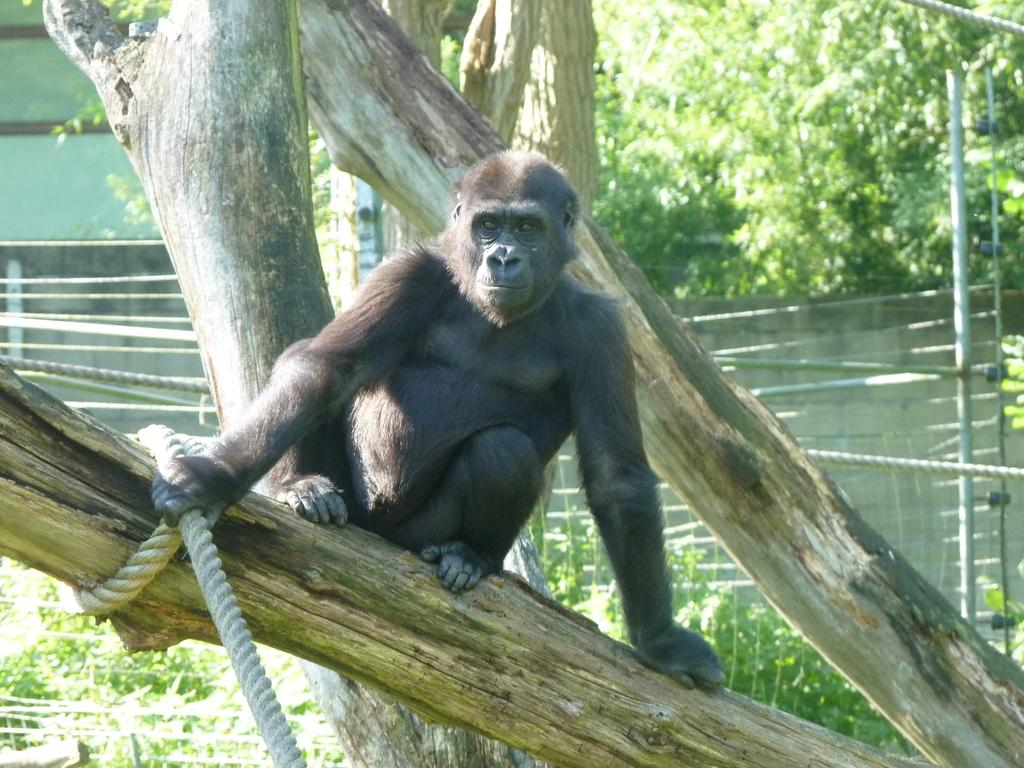What animal is present in the image? There is a chimpanzee in the image. Where is the chimpanzee located? The chimpanzee is on a branch of a tree. What is the chimpanzee holding in the image? The chimpanzee is holding a white-colored rope. What can be seen in the background of the image? There is a pole, fencing, a boundary wall, and trees in the background of the image. What type of coat is the chimpanzee wearing in the image? There is no coat present in the image; the chimpanzee is not wearing any clothing. What type of order is the chimpanzee following in the image? There is no order or instruction being followed by the chimpanzee in the image. 